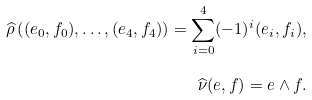Convert formula to latex. <formula><loc_0><loc_0><loc_500><loc_500>\widehat { \rho } \left ( ( e _ { 0 } , f _ { 0 } ) , \dots , ( e _ { 4 } , f _ { 4 } ) \right ) = \sum _ { i = 0 } ^ { 4 } ( - 1 ) ^ { i } ( e _ { i } , f _ { i } ) , \\ \widehat { \nu } ( e , f ) = e \wedge f .</formula> 